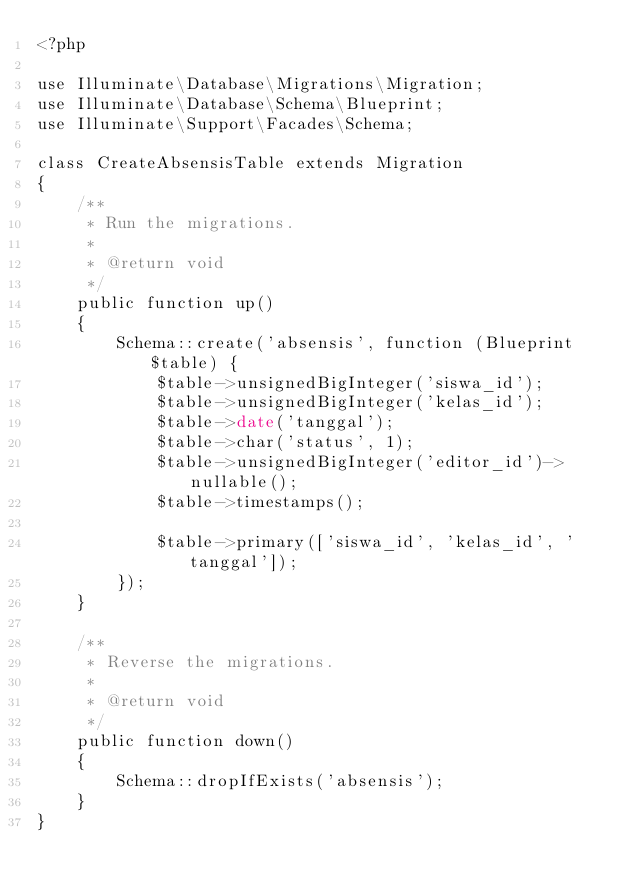Convert code to text. <code><loc_0><loc_0><loc_500><loc_500><_PHP_><?php

use Illuminate\Database\Migrations\Migration;
use Illuminate\Database\Schema\Blueprint;
use Illuminate\Support\Facades\Schema;

class CreateAbsensisTable extends Migration
{
    /**
     * Run the migrations.
     *
     * @return void
     */
    public function up()
    {
        Schema::create('absensis', function (Blueprint $table) {
            $table->unsignedBigInteger('siswa_id');
            $table->unsignedBigInteger('kelas_id');
            $table->date('tanggal');
            $table->char('status', 1);
            $table->unsignedBigInteger('editor_id')->nullable();
            $table->timestamps();

            $table->primary(['siswa_id', 'kelas_id', 'tanggal']);
        });
    }

    /**
     * Reverse the migrations.
     *
     * @return void
     */
    public function down()
    {
        Schema::dropIfExists('absensis');
    }
}
</code> 